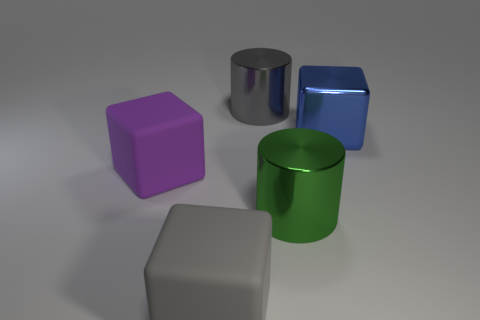Is the color of the large metallic block the same as the big metal thing to the left of the large green thing?
Your answer should be compact. No. The gray object that is the same shape as the big blue thing is what size?
Offer a very short reply. Large. The object that is behind the big gray rubber thing and in front of the purple cube has what shape?
Give a very brief answer. Cylinder. Is the size of the purple thing the same as the gray matte object left of the big metallic cube?
Offer a very short reply. Yes. What is the color of the other big metallic object that is the same shape as the big purple thing?
Ensure brevity in your answer.  Blue. Does the metallic object in front of the blue cube have the same size as the gray block left of the blue thing?
Your answer should be very brief. Yes. Does the purple object have the same shape as the large gray metallic object?
Keep it short and to the point. No. How many things are big metal objects that are on the right side of the gray metallic cylinder or metal objects?
Offer a terse response. 3. Is there a tiny yellow rubber thing that has the same shape as the large blue metallic thing?
Your answer should be very brief. No. Is the number of large purple rubber cubes left of the green cylinder the same as the number of blue objects?
Provide a short and direct response. Yes. 